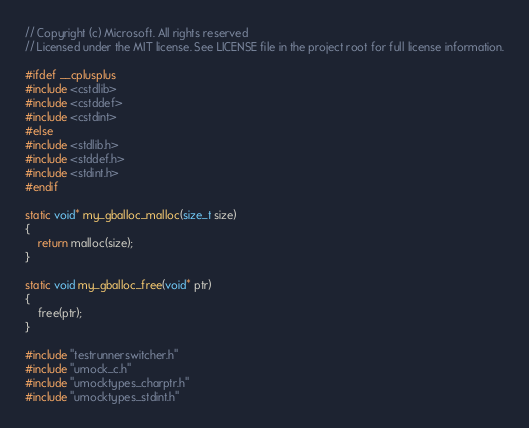<code> <loc_0><loc_0><loc_500><loc_500><_C_>// Copyright (c) Microsoft. All rights reserved
// Licensed under the MIT license. See LICENSE file in the project root for full license information.

#ifdef __cplusplus
#include <cstdlib>
#include <cstddef>
#include <cstdint>
#else
#include <stdlib.h>
#include <stddef.h>
#include <stdint.h>
#endif

static void* my_gballoc_malloc(size_t size)
{
    return malloc(size);
}

static void my_gballoc_free(void* ptr)
{
    free(ptr);
}

#include "testrunnerswitcher.h"
#include "umock_c.h"
#include "umocktypes_charptr.h"
#include "umocktypes_stdint.h"</code> 